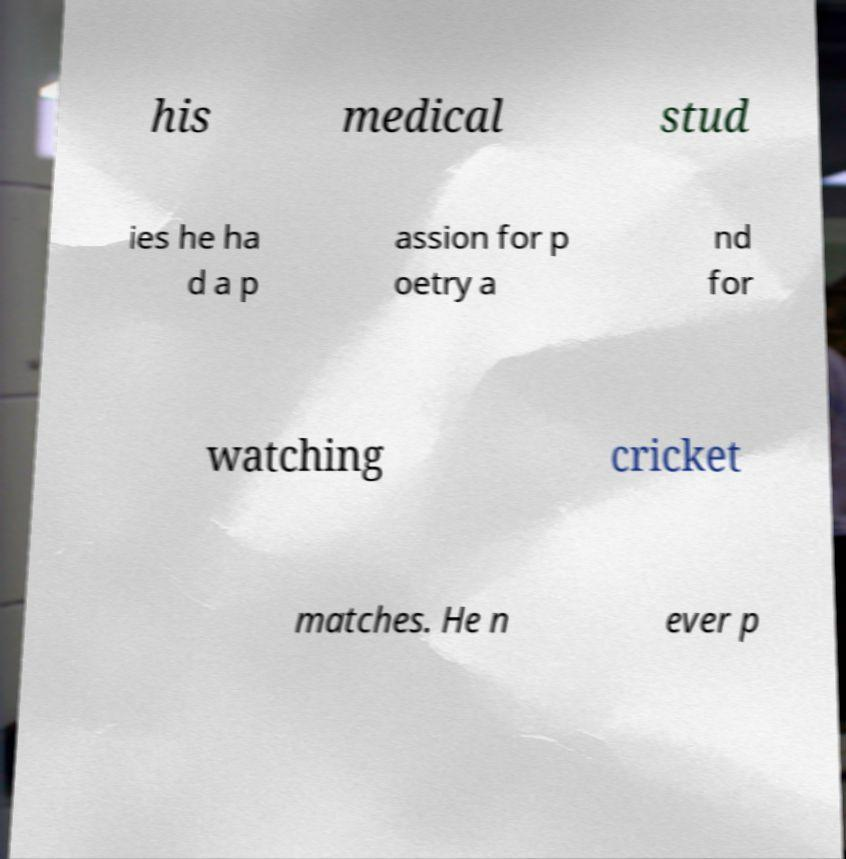Please read and relay the text visible in this image. What does it say? his medical stud ies he ha d a p assion for p oetry a nd for watching cricket matches. He n ever p 